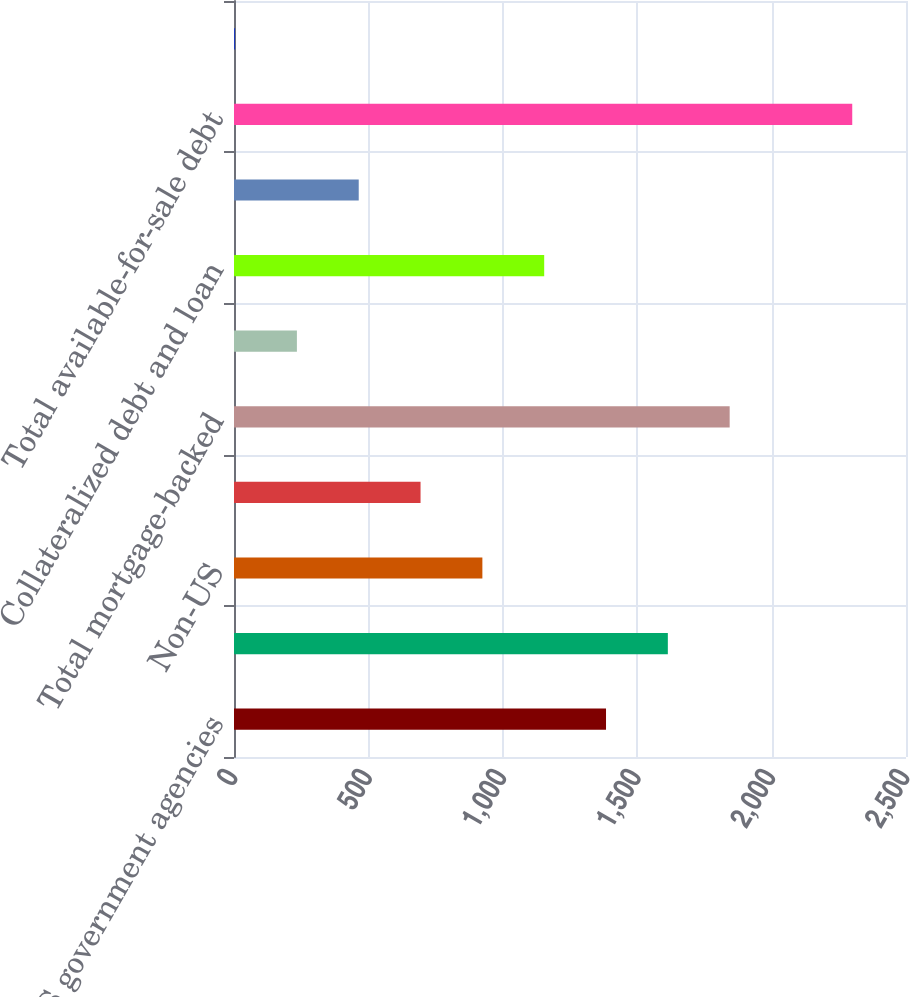Convert chart to OTSL. <chart><loc_0><loc_0><loc_500><loc_500><bar_chart><fcel>US government agencies<fcel>Prime and Alt-A<fcel>Non-US<fcel>Commercial<fcel>Total mortgage-backed<fcel>Obligations of US states and<fcel>Collateralized debt and loan<fcel>Other<fcel>Total available-for-sale debt<fcel>Available-for-sale equity<nl><fcel>1384<fcel>1614<fcel>924<fcel>694<fcel>1844<fcel>234<fcel>1154<fcel>464<fcel>2300<fcel>4<nl></chart> 